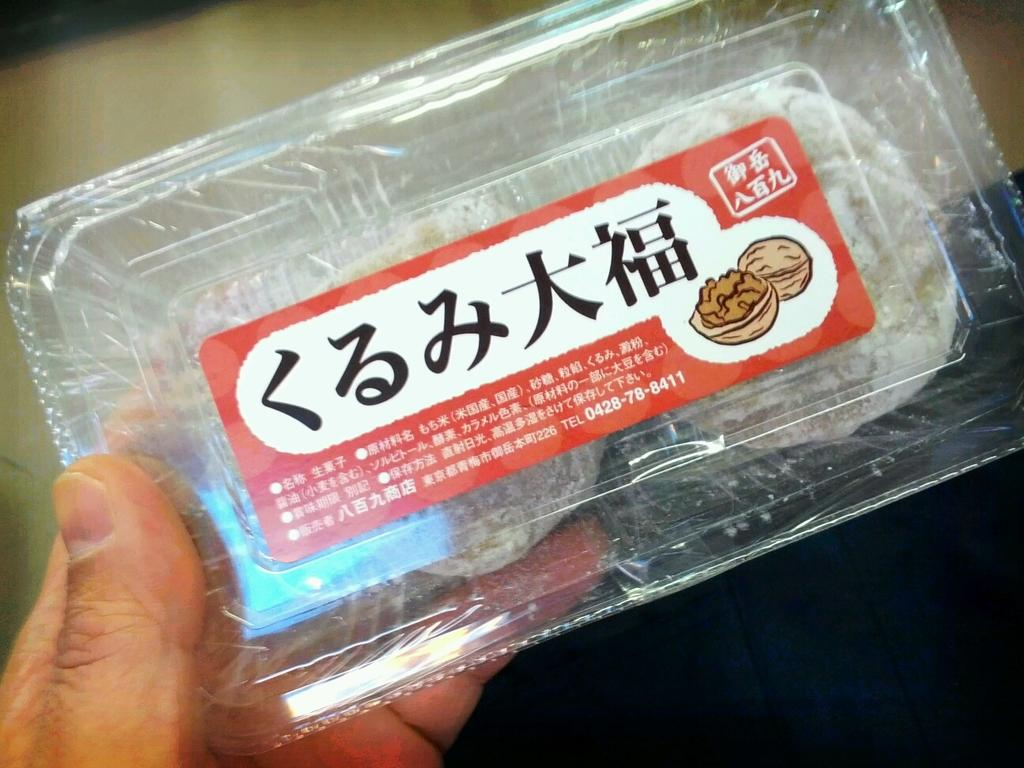What is being held in the left corner of the image? There is a hand holding a box in the left corner of the image. Is there any additional information about the box in the image? Yes, there is a paper attached to the box in the image. How does the hand holding the box in the image embark on a voyage? The hand holding the box in the image is not embarking on a voyage, as it is a static image and not a living entity. 